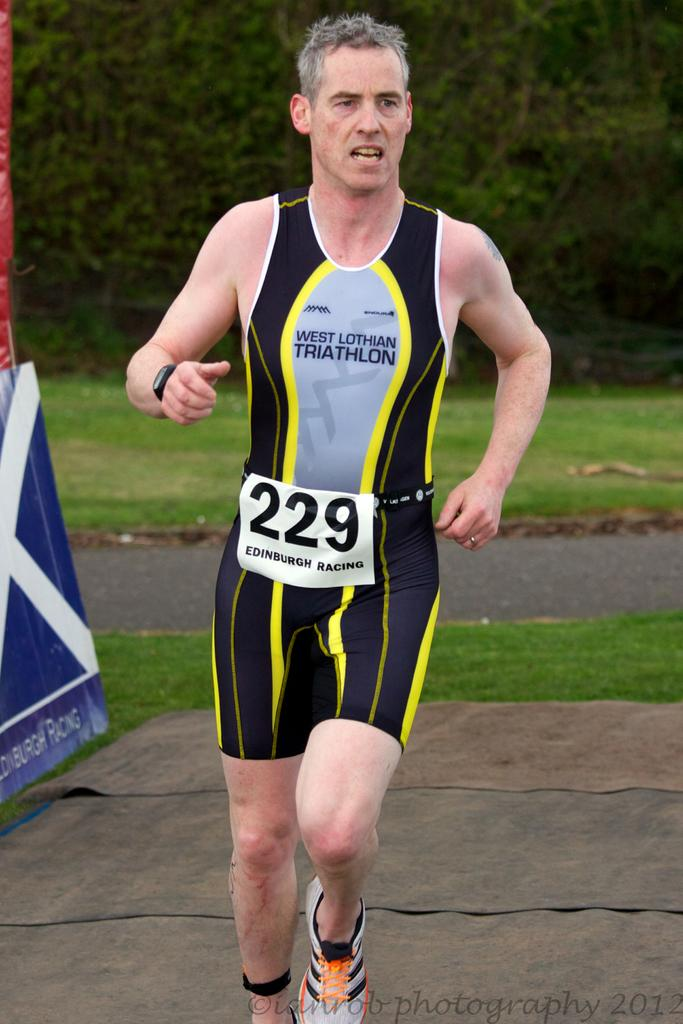<image>
Render a clear and concise summary of the photo. Runner 229 runs in the west lothian triathlon wearing black and yellow. 